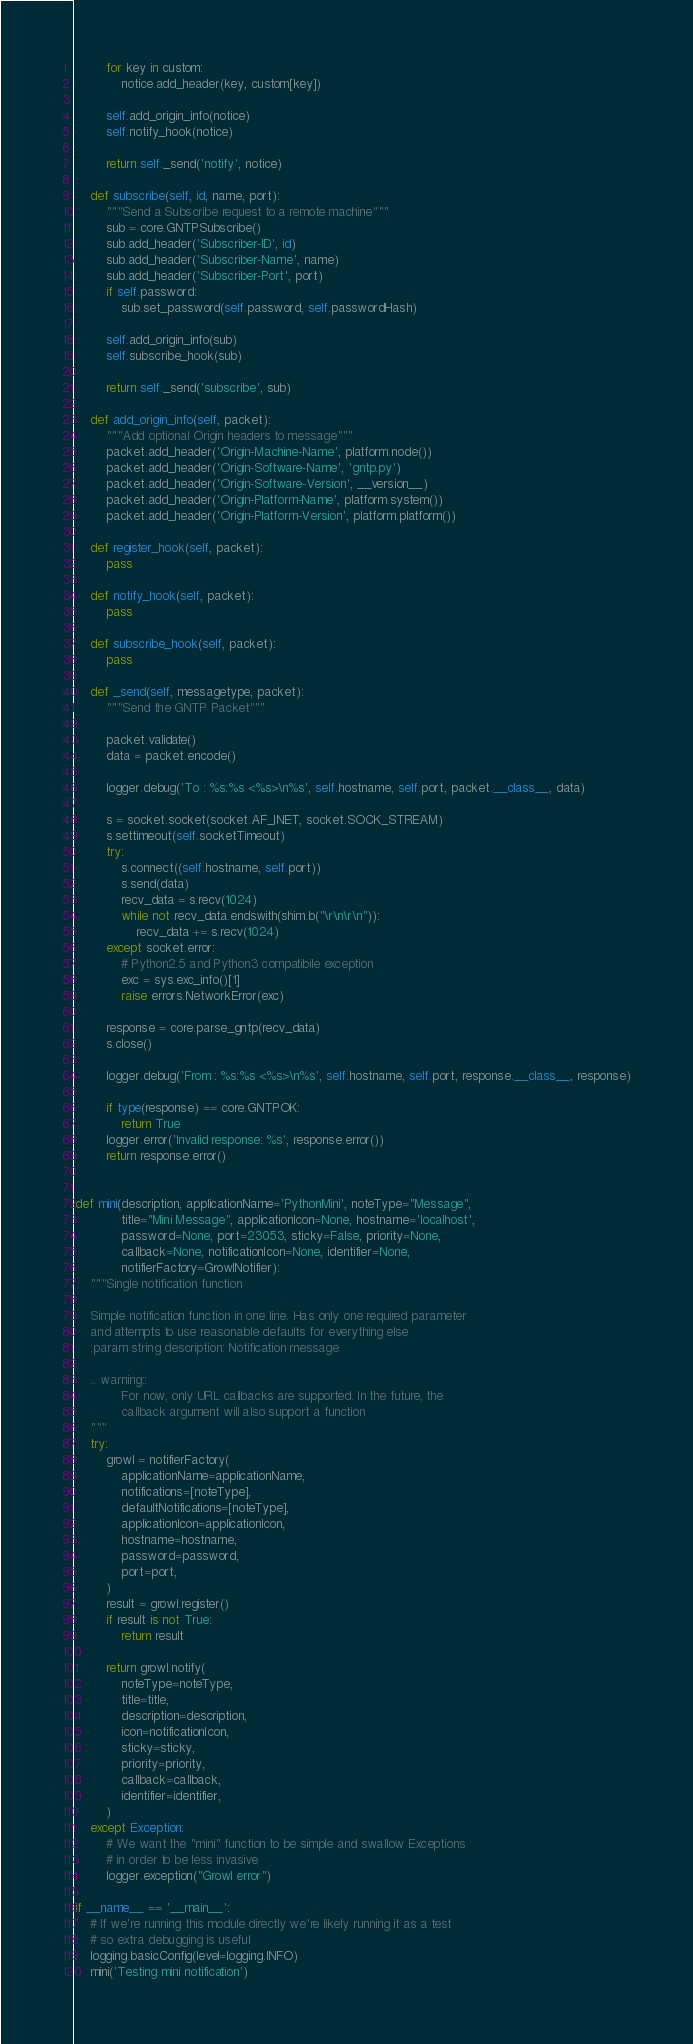Convert code to text. <code><loc_0><loc_0><loc_500><loc_500><_Python_>		for key in custom:
			notice.add_header(key, custom[key])

		self.add_origin_info(notice)
		self.notify_hook(notice)

		return self._send('notify', notice)

	def subscribe(self, id, name, port):
		"""Send a Subscribe request to a remote machine"""
		sub = core.GNTPSubscribe()
		sub.add_header('Subscriber-ID', id)
		sub.add_header('Subscriber-Name', name)
		sub.add_header('Subscriber-Port', port)
		if self.password:
			sub.set_password(self.password, self.passwordHash)

		self.add_origin_info(sub)
		self.subscribe_hook(sub)

		return self._send('subscribe', sub)

	def add_origin_info(self, packet):
		"""Add optional Origin headers to message"""
		packet.add_header('Origin-Machine-Name', platform.node())
		packet.add_header('Origin-Software-Name', 'gntp.py')
		packet.add_header('Origin-Software-Version', __version__)
		packet.add_header('Origin-Platform-Name', platform.system())
		packet.add_header('Origin-Platform-Version', platform.platform())

	def register_hook(self, packet):
		pass

	def notify_hook(self, packet):
		pass

	def subscribe_hook(self, packet):
		pass

	def _send(self, messagetype, packet):
		"""Send the GNTP Packet"""

		packet.validate()
		data = packet.encode()

		logger.debug('To : %s:%s <%s>\n%s', self.hostname, self.port, packet.__class__, data)

		s = socket.socket(socket.AF_INET, socket.SOCK_STREAM)
		s.settimeout(self.socketTimeout)
		try:
			s.connect((self.hostname, self.port))
			s.send(data)
			recv_data = s.recv(1024)
			while not recv_data.endswith(shim.b("\r\n\r\n")):
				recv_data += s.recv(1024)
		except socket.error:
			# Python2.5 and Python3 compatibile exception
			exc = sys.exc_info()[1]
			raise errors.NetworkError(exc)

		response = core.parse_gntp(recv_data)
		s.close()

		logger.debug('From : %s:%s <%s>\n%s', self.hostname, self.port, response.__class__, response)

		if type(response) == core.GNTPOK:
			return True
		logger.error('Invalid response: %s', response.error())
		return response.error()


def mini(description, applicationName='PythonMini', noteType="Message",
			title="Mini Message", applicationIcon=None, hostname='localhost',
			password=None, port=23053, sticky=False, priority=None,
			callback=None, notificationIcon=None, identifier=None,
			notifierFactory=GrowlNotifier):
	"""Single notification function

	Simple notification function in one line. Has only one required parameter
	and attempts to use reasonable defaults for everything else
	:param string description: Notification message

	.. warning::
			For now, only URL callbacks are supported. In the future, the
			callback argument will also support a function
	"""
	try:
		growl = notifierFactory(
			applicationName=applicationName,
			notifications=[noteType],
			defaultNotifications=[noteType],
			applicationIcon=applicationIcon,
			hostname=hostname,
			password=password,
			port=port,
		)
		result = growl.register()
		if result is not True:
			return result

		return growl.notify(
			noteType=noteType,
			title=title,
			description=description,
			icon=notificationIcon,
			sticky=sticky,
			priority=priority,
			callback=callback,
			identifier=identifier,
		)
	except Exception:
		# We want the "mini" function to be simple and swallow Exceptions
		# in order to be less invasive
		logger.exception("Growl error")

if __name__ == '__main__':
	# If we're running this module directly we're likely running it as a test
	# so extra debugging is useful
	logging.basicConfig(level=logging.INFO)
	mini('Testing mini notification')
</code> 